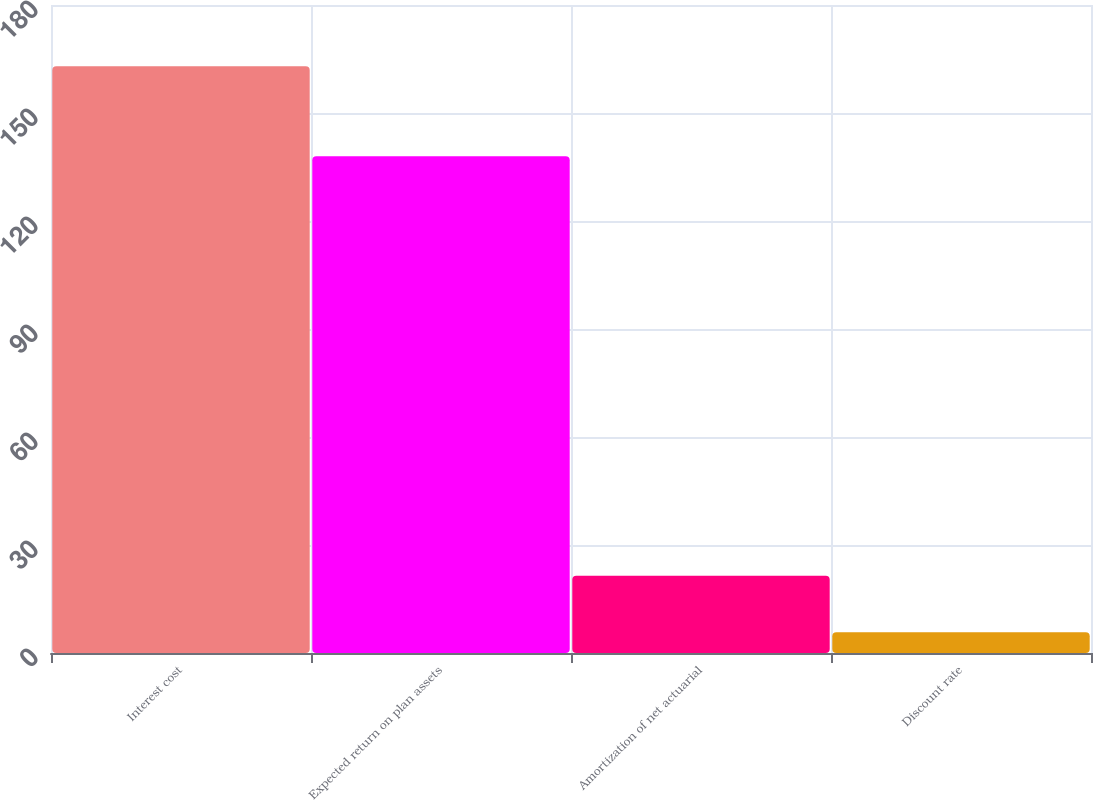Convert chart. <chart><loc_0><loc_0><loc_500><loc_500><bar_chart><fcel>Interest cost<fcel>Expected return on plan assets<fcel>Amortization of net actuarial<fcel>Discount rate<nl><fcel>163<fcel>138<fcel>21.48<fcel>5.75<nl></chart> 